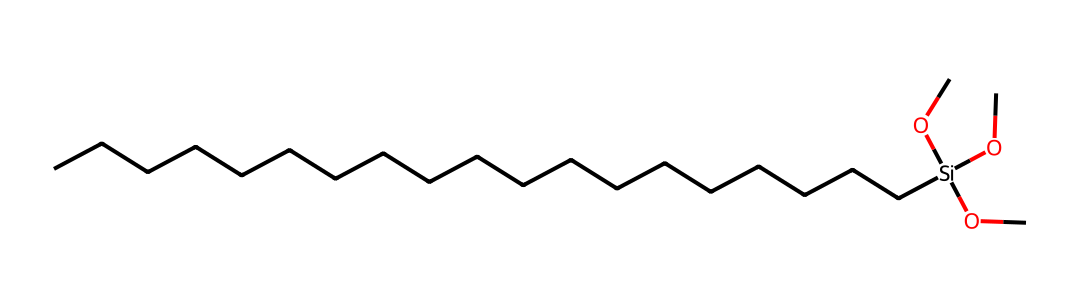What is the main functional group present in this silane? The structure shows several alkoxy groups (–O–), indicating that it is an alkoxysilane. This can be observed from the presence of three –OC groups attached to the silicon atom.
Answer: alkoxysilane How many carbon atoms are present in this molecule? By counting the carbon atoms from the long hydrocarbon chain and the three alkoxy groups, a total of 18 carbon atoms can be determined. The hydrocarbon chain connected to silicon has 16 carbons, and each alkoxy group contributes one carbon.
Answer: 18 What type of bonding occurs between silicon and oxygen in this silane? The silicon atom within the structure forms covalent bonds with the oxygen atoms of the –O– groups, which can be confirmed by identifying the Si-O connections in the chemical structure.
Answer: covalent Is this silane likely to be hydrophobic or hydrophilic? Given the long hydrocarbon chain (with many carbon atoms) and the presence of alkoxy groups, this silane is likely to exhibit hydrophobic properties, leading to water repellency when applied to fabrics.
Answer: hydrophobic What is the degree of saturation of the hydrocarbon chain in this silane? The carbon chain is fully saturated, meaning it has single C-C bonds with no double or triple bonds indicated in the structure, which can be observed by analyzing the types of bonds present in the hydrocarbon chain.
Answer: saturated 